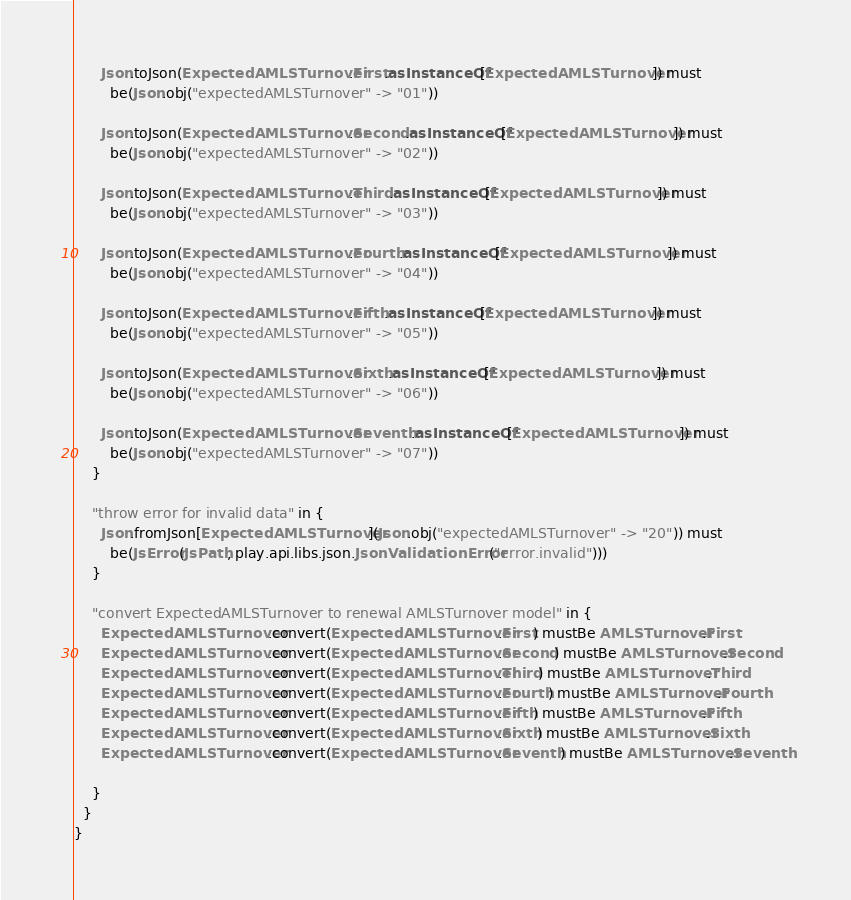Convert code to text. <code><loc_0><loc_0><loc_500><loc_500><_Scala_>      Json.toJson(ExpectedAMLSTurnover.First.asInstanceOf[ExpectedAMLSTurnover]) must
        be(Json.obj("expectedAMLSTurnover" -> "01"))

      Json.toJson(ExpectedAMLSTurnover.Second.asInstanceOf[ExpectedAMLSTurnover]) must
        be(Json.obj("expectedAMLSTurnover" -> "02"))

      Json.toJson(ExpectedAMLSTurnover.Third.asInstanceOf[ExpectedAMLSTurnover]) must
        be(Json.obj("expectedAMLSTurnover" -> "03"))

      Json.toJson(ExpectedAMLSTurnover.Fourth.asInstanceOf[ExpectedAMLSTurnover]) must
        be(Json.obj("expectedAMLSTurnover" -> "04"))

      Json.toJson(ExpectedAMLSTurnover.Fifth.asInstanceOf[ExpectedAMLSTurnover]) must
        be(Json.obj("expectedAMLSTurnover" -> "05"))

      Json.toJson(ExpectedAMLSTurnover.Sixth.asInstanceOf[ExpectedAMLSTurnover]) must
        be(Json.obj("expectedAMLSTurnover" -> "06"))

      Json.toJson(ExpectedAMLSTurnover.Seventh.asInstanceOf[ExpectedAMLSTurnover]) must
        be(Json.obj("expectedAMLSTurnover" -> "07"))
    }

    "throw error for invalid data" in {
      Json.fromJson[ExpectedAMLSTurnover](Json.obj("expectedAMLSTurnover" -> "20")) must
        be(JsError(JsPath, play.api.libs.json.JsonValidationError("error.invalid")))
    }

    "convert ExpectedAMLSTurnover to renewal AMLSTurnover model" in {
      ExpectedAMLSTurnover.convert(ExpectedAMLSTurnover.First) mustBe AMLSTurnover.First
      ExpectedAMLSTurnover.convert(ExpectedAMLSTurnover.Second) mustBe AMLSTurnover.Second
      ExpectedAMLSTurnover.convert(ExpectedAMLSTurnover.Third) mustBe AMLSTurnover.Third
      ExpectedAMLSTurnover.convert(ExpectedAMLSTurnover.Fourth) mustBe AMLSTurnover.Fourth
      ExpectedAMLSTurnover.convert(ExpectedAMLSTurnover.Fifth) mustBe AMLSTurnover.Fifth
      ExpectedAMLSTurnover.convert(ExpectedAMLSTurnover.Sixth) mustBe AMLSTurnover.Sixth
      ExpectedAMLSTurnover.convert(ExpectedAMLSTurnover.Seventh) mustBe AMLSTurnover.Seventh

    }
  }
}
</code> 